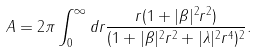Convert formula to latex. <formula><loc_0><loc_0><loc_500><loc_500>A = 2 \pi \int ^ { \infty } _ { 0 } d r \frac { r ( 1 + | \beta | ^ { 2 } r ^ { 2 } ) } { ( 1 + | \beta | ^ { 2 } r ^ { 2 } + | \lambda | ^ { 2 } r ^ { 4 } ) ^ { 2 } } .</formula> 